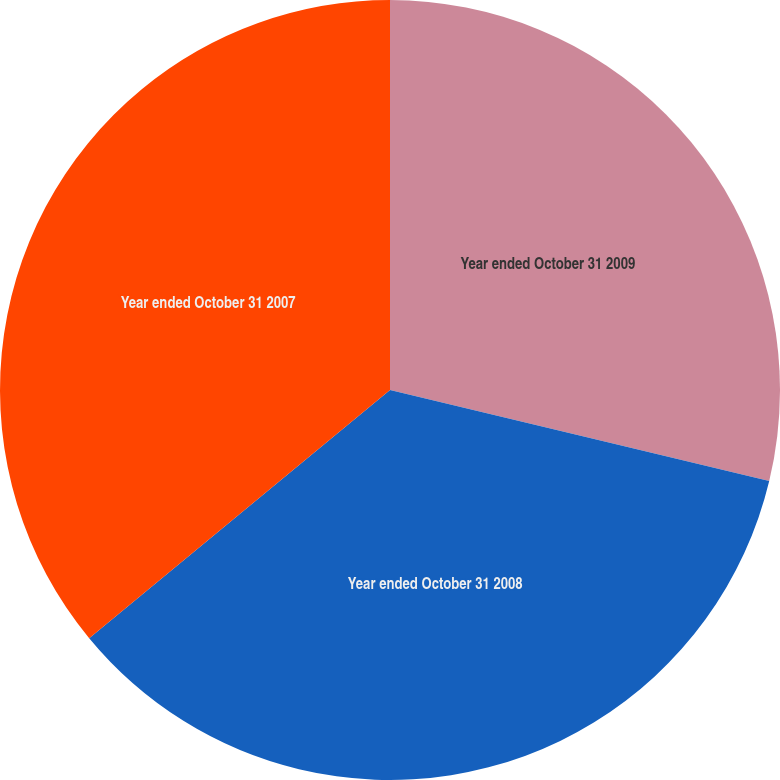Convert chart to OTSL. <chart><loc_0><loc_0><loc_500><loc_500><pie_chart><fcel>Year ended October 31 2009<fcel>Year ended October 31 2008<fcel>Year ended October 31 2007<nl><fcel>28.75%<fcel>35.27%<fcel>35.98%<nl></chart> 